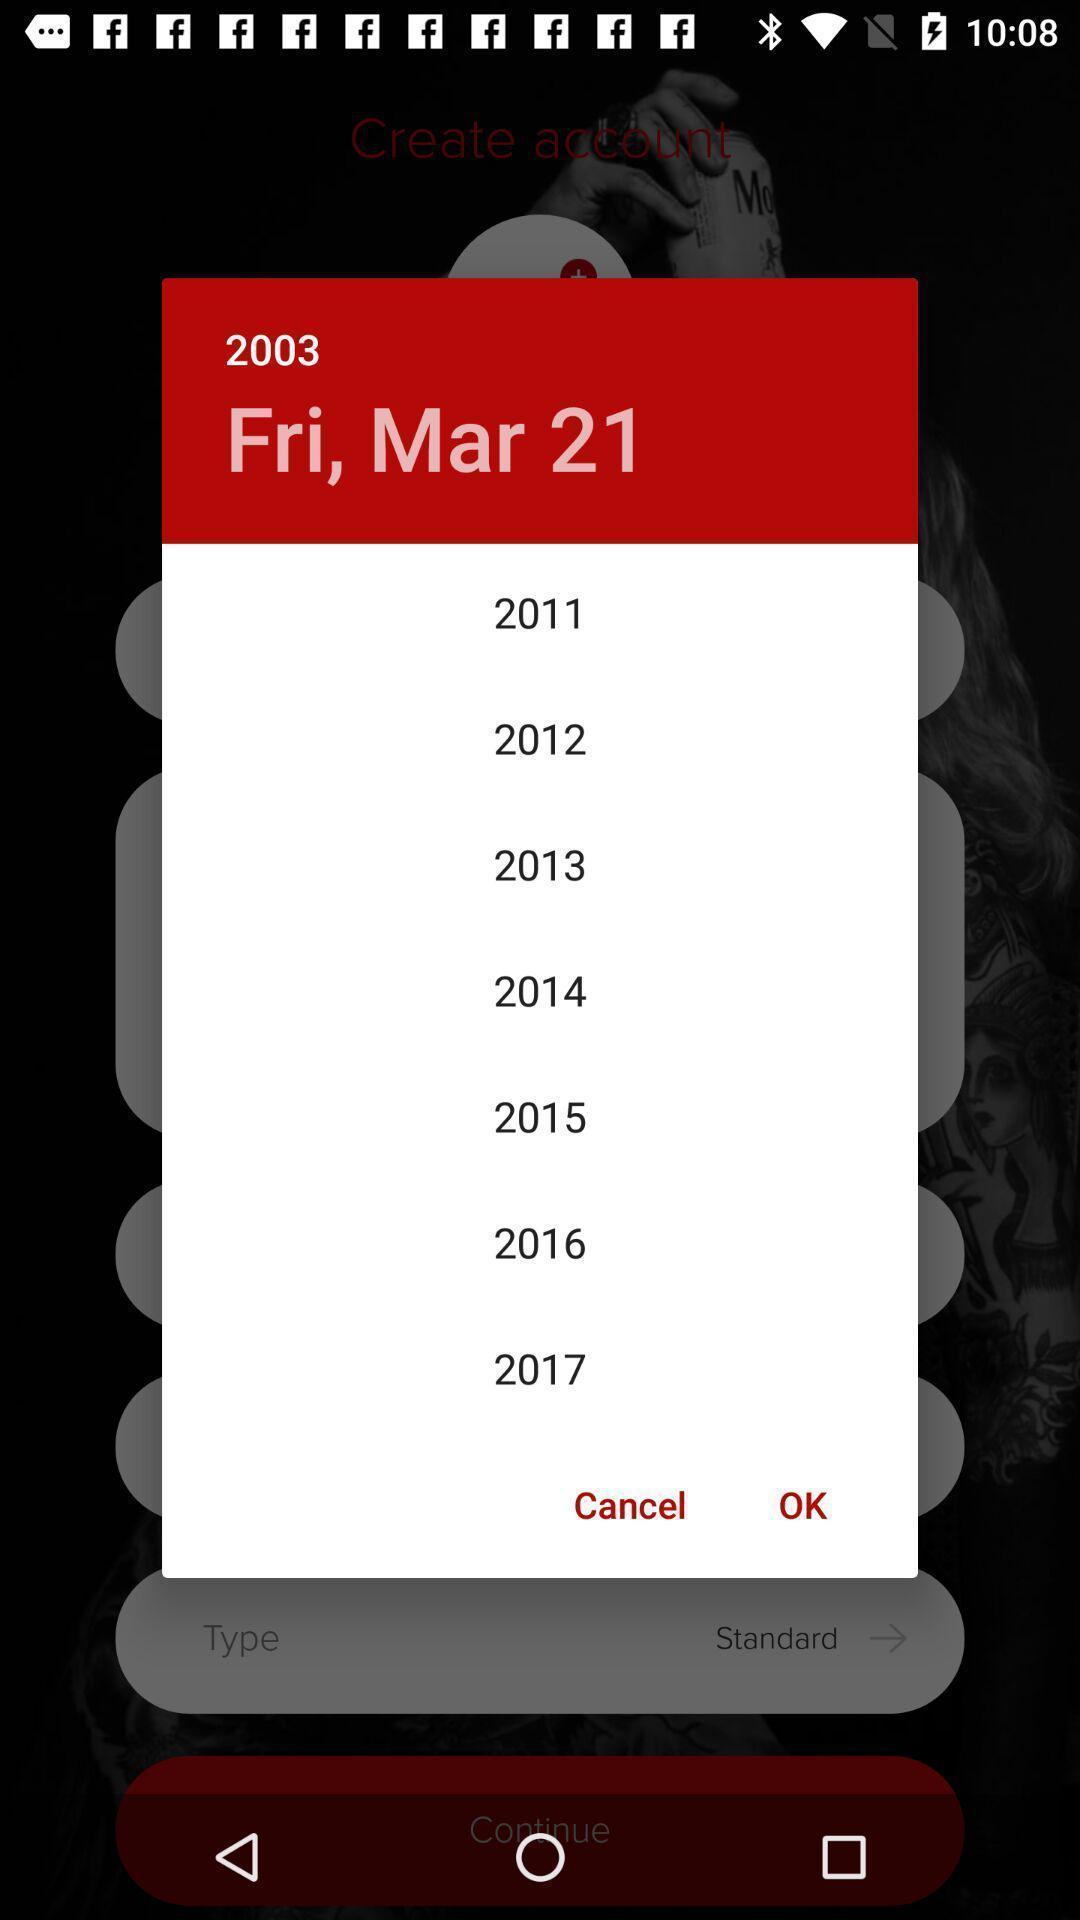Tell me about the visual elements in this screen capture. Popup showing year to select. 